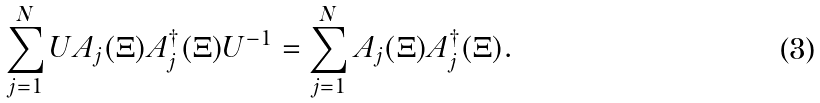<formula> <loc_0><loc_0><loc_500><loc_500>\sum _ { j = 1 } ^ { N } U A _ { j } ( \Xi ) A _ { j } ^ { \dagger } ( \Xi ) U ^ { - 1 } = \sum _ { j = 1 } ^ { N } A _ { j } ( \Xi ) A _ { j } ^ { \dagger } ( \Xi ) .</formula> 